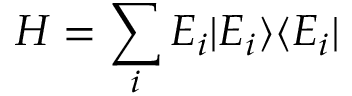Convert formula to latex. <formula><loc_0><loc_0><loc_500><loc_500>H = \sum _ { i } E _ { i } | E _ { i } \rangle \langle E _ { i } |</formula> 